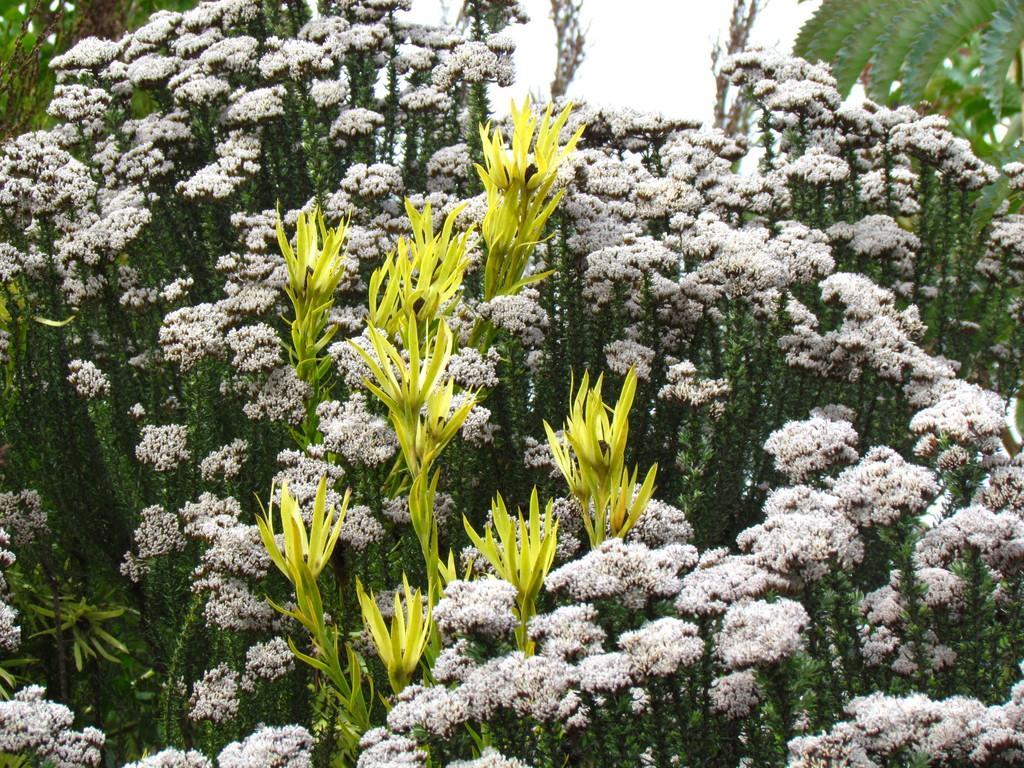Please provide a concise description of this image. In this picture we can see the flowers on the plant. At the top there is a sky. On the right we can see the leaves. 